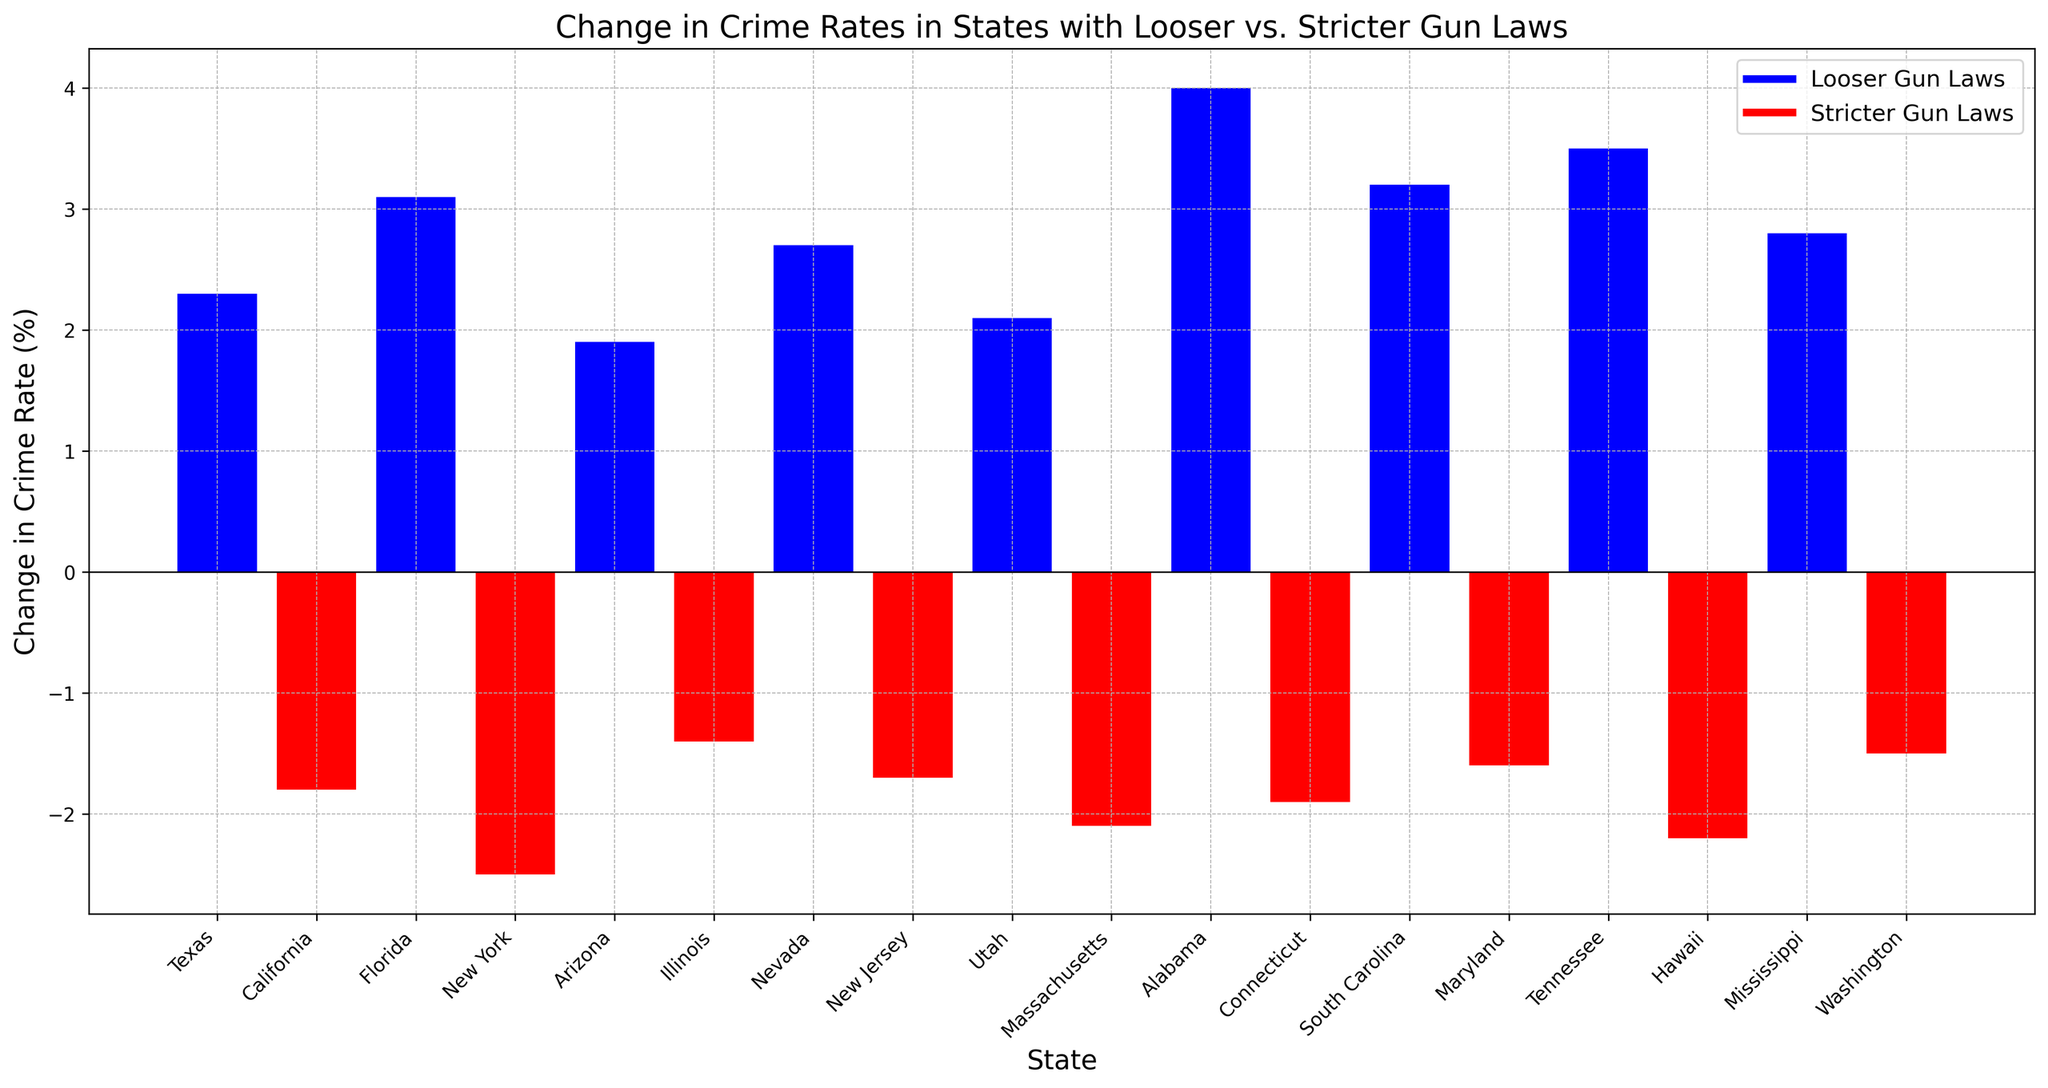Which state has the highest positive change in crime rate? To find the highest positive change, look for the tallest bar above the horizontal line (y = 0). The tallest positive bar is for Alabama.
Answer: Alabama Which state has the lowest negative change in crime rate? To identify the lowest negative change, look for the smallest (closest to 0) value beneath the horizontal line (y = 0). The shortest negative bar is for Illinois.
Answer: Illinois What is the difference in the change in crime rate between Florida and New York? Florida has a positive change of 3.1% while New York has a negative change of -2.5%. The difference is calculated as 3.1 - (-2.5) = 3.1 + 2.5 = 5.6%.
Answer: 5.6% How many states with stricter gun laws have a decrease in crime rates? Count the number of red bars (representing stricter gun laws) that are below the horizontal line (y = 0). There are eight such states.
Answer: 8 What's the average change in crime rate for states with looser gun laws? Add the change in crime rates for all states with looser gun laws and then divide by the number of these states. (2.3 + 3.1 + 1.9 + 2.7 + 2.1 + 4.0 + 3.2 + 3.5 + 2.8) / 9 = 25.6 / 9 ≈ 2.84%.
Answer: 2.84% Which states have a change in crime rate between 2% and 3%? Look for bars whose heights correspond to changes between 2% and 3%. These states are Texas, Arizona, Nevada, Utah, and Mississippi.
Answer: Texas, Arizona, Nevada, Utah, Mississippi Do more states with looser or stricter gun laws have negative changes in the crime rate? Count the number of bars below the horizontal line for each type of gun law. States with stricter gun laws have more negative changes (all stricter law states have negative changes).
Answer: Stricter gun laws What's the combined change in crime rates for California and Massachusetts? Both states have stricter gun laws and negative changes. The combined change is -1.8% (California) + -2.1% (Massachusetts) = -3.9%.
Answer: -3.9% 